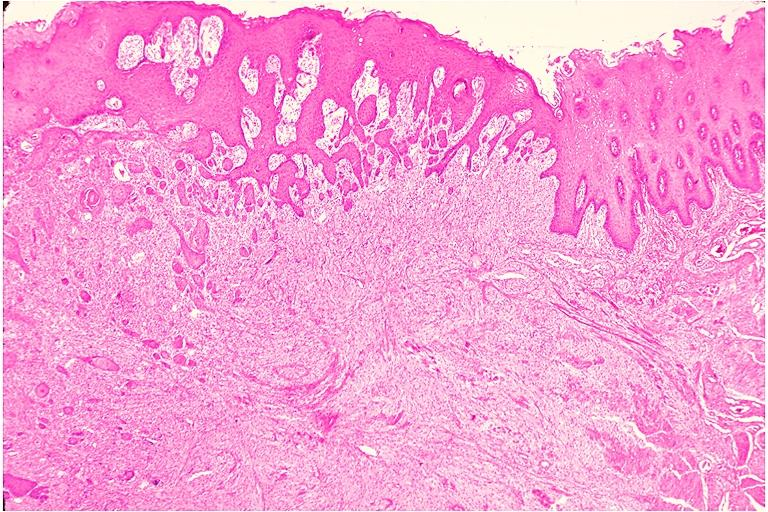what does this image show?
Answer the question using a single word or phrase. Granular cell tumor 